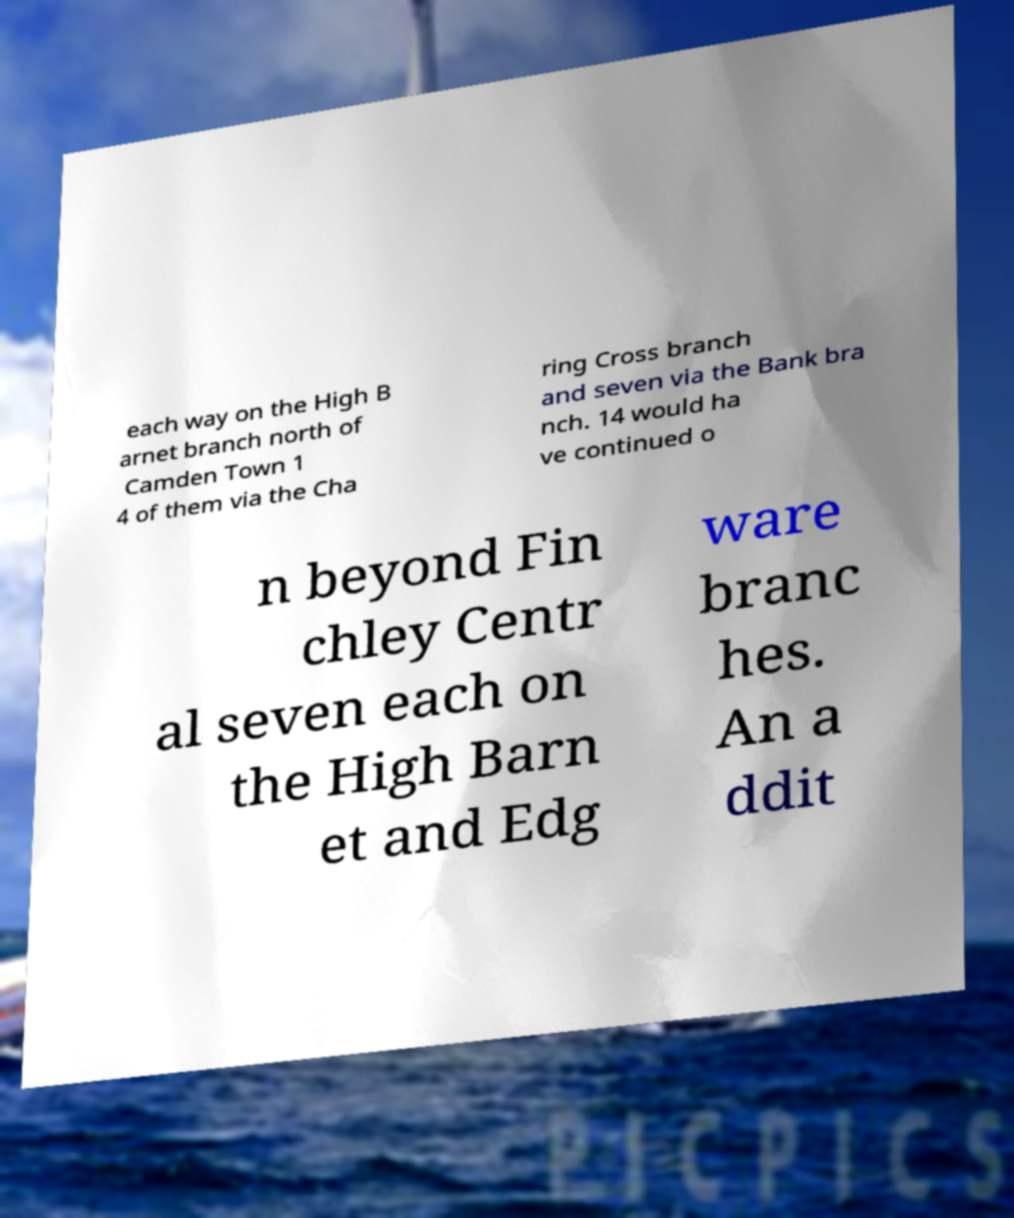For documentation purposes, I need the text within this image transcribed. Could you provide that? each way on the High B arnet branch north of Camden Town 1 4 of them via the Cha ring Cross branch and seven via the Bank bra nch. 14 would ha ve continued o n beyond Fin chley Centr al seven each on the High Barn et and Edg ware branc hes. An a ddit 